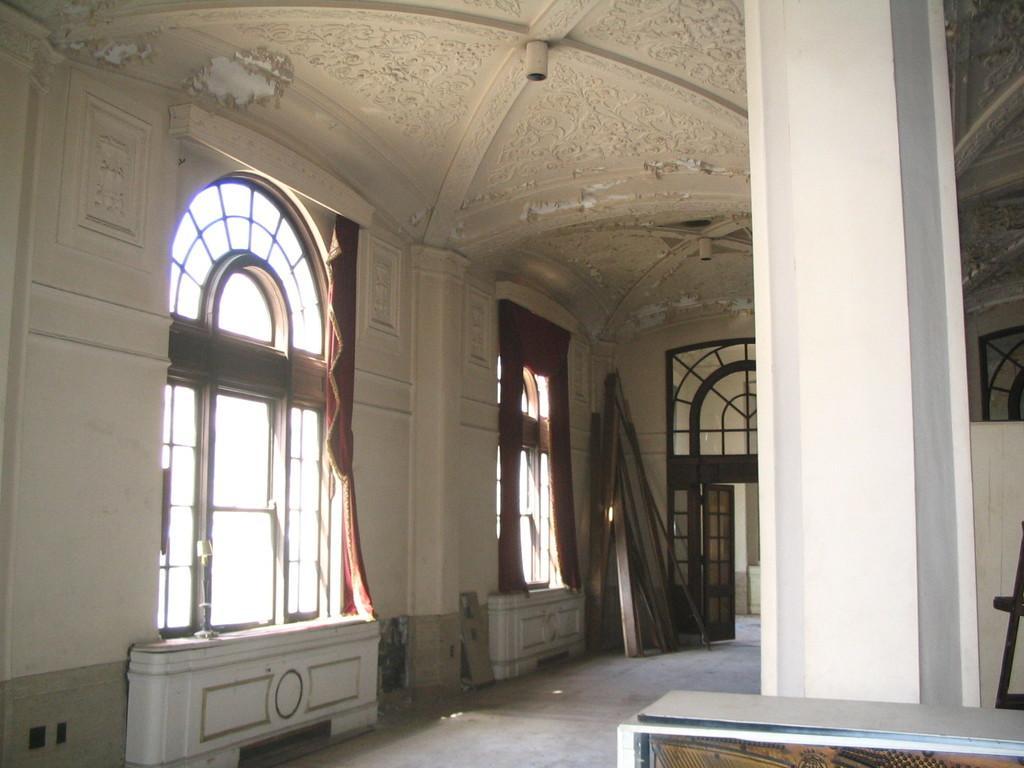How would you summarize this image in a sentence or two? This is the inside picture of the building and there are few wooden sticks at the corner of the building. 